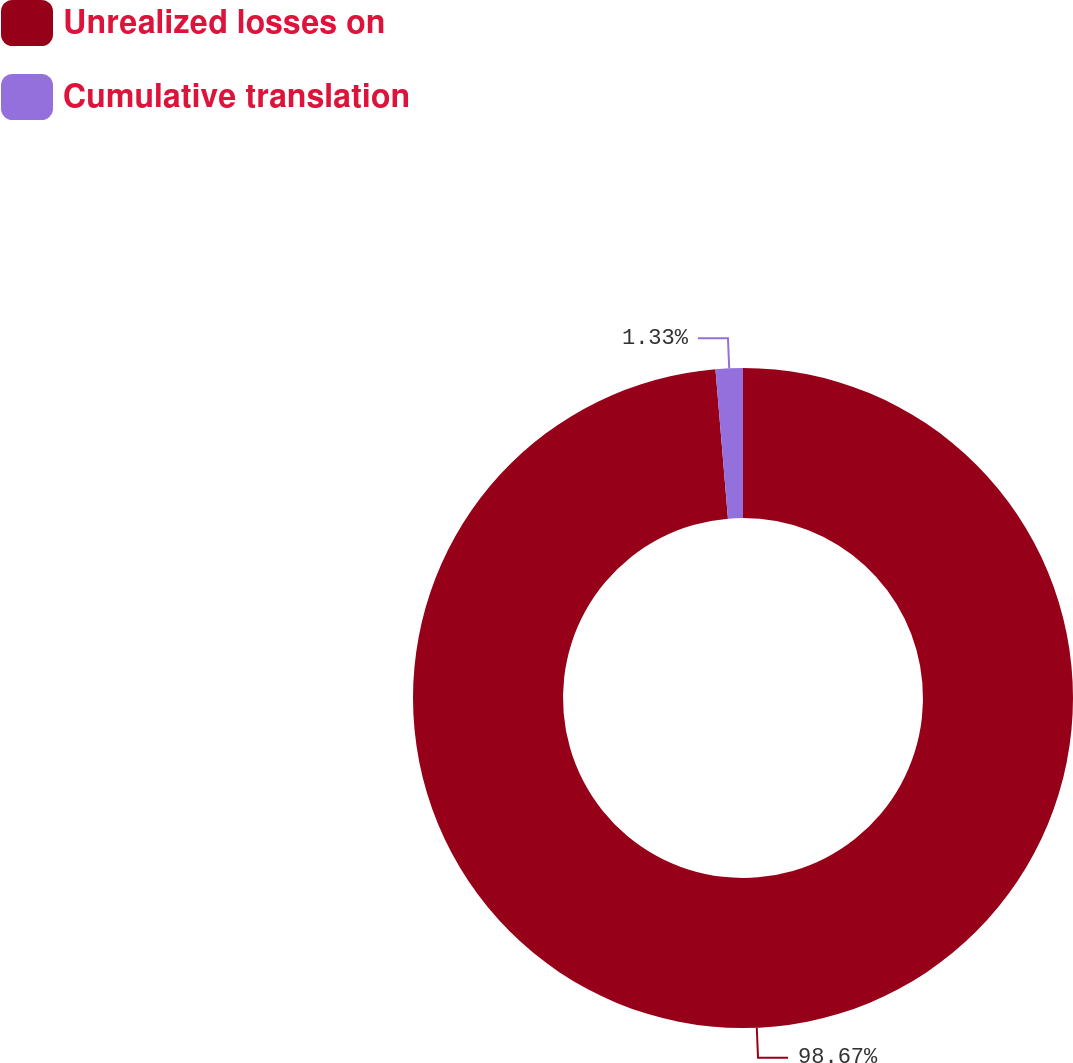Convert chart. <chart><loc_0><loc_0><loc_500><loc_500><pie_chart><fcel>Unrealized losses on<fcel>Cumulative translation<nl><fcel>98.67%<fcel>1.33%<nl></chart> 